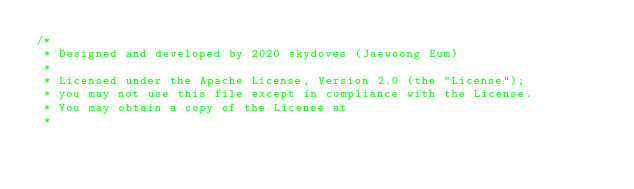Convert code to text. <code><loc_0><loc_0><loc_500><loc_500><_Kotlin_>/*
 * Designed and developed by 2020 skydoves (Jaewoong Eum)
 *
 * Licensed under the Apache License, Version 2.0 (the "License");
 * you may not use this file except in compliance with the License.
 * You may obtain a copy of the License at
 *</code> 